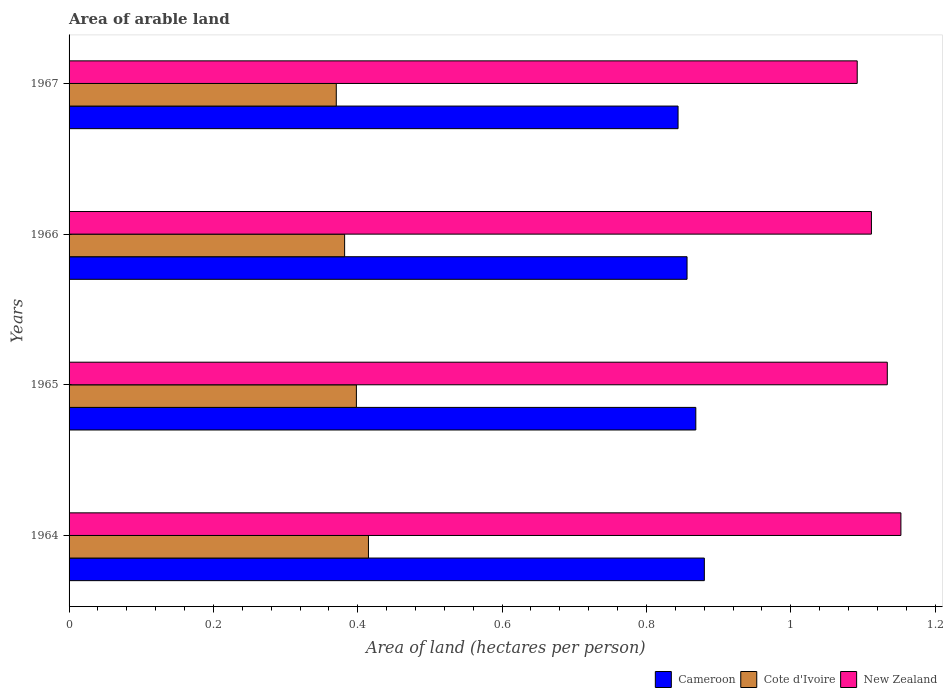How many different coloured bars are there?
Provide a short and direct response. 3. Are the number of bars per tick equal to the number of legend labels?
Offer a terse response. Yes. How many bars are there on the 4th tick from the top?
Make the answer very short. 3. How many bars are there on the 1st tick from the bottom?
Offer a terse response. 3. What is the label of the 4th group of bars from the top?
Make the answer very short. 1964. What is the total arable land in New Zealand in 1966?
Offer a very short reply. 1.11. Across all years, what is the maximum total arable land in Cote d'Ivoire?
Ensure brevity in your answer.  0.41. Across all years, what is the minimum total arable land in New Zealand?
Your answer should be compact. 1.09. In which year was the total arable land in Cameroon maximum?
Keep it short and to the point. 1964. In which year was the total arable land in Cameroon minimum?
Your response must be concise. 1967. What is the total total arable land in New Zealand in the graph?
Offer a terse response. 4.49. What is the difference between the total arable land in Cameroon in 1965 and that in 1967?
Provide a short and direct response. 0.02. What is the difference between the total arable land in Cote d'Ivoire in 1964 and the total arable land in Cameroon in 1967?
Keep it short and to the point. -0.43. What is the average total arable land in Cote d'Ivoire per year?
Keep it short and to the point. 0.39. In the year 1964, what is the difference between the total arable land in Cameroon and total arable land in Cote d'Ivoire?
Your answer should be very brief. 0.47. What is the ratio of the total arable land in Cameroon in 1965 to that in 1967?
Provide a short and direct response. 1.03. Is the difference between the total arable land in Cameroon in 1966 and 1967 greater than the difference between the total arable land in Cote d'Ivoire in 1966 and 1967?
Provide a short and direct response. Yes. What is the difference between the highest and the second highest total arable land in Cameroon?
Your answer should be very brief. 0.01. What is the difference between the highest and the lowest total arable land in Cote d'Ivoire?
Make the answer very short. 0.04. What does the 3rd bar from the top in 1966 represents?
Ensure brevity in your answer.  Cameroon. What does the 3rd bar from the bottom in 1966 represents?
Your answer should be compact. New Zealand. Is it the case that in every year, the sum of the total arable land in Cote d'Ivoire and total arable land in New Zealand is greater than the total arable land in Cameroon?
Make the answer very short. Yes. How many bars are there?
Provide a succinct answer. 12. How many years are there in the graph?
Your answer should be compact. 4. How are the legend labels stacked?
Offer a terse response. Horizontal. What is the title of the graph?
Offer a very short reply. Area of arable land. What is the label or title of the X-axis?
Provide a short and direct response. Area of land (hectares per person). What is the label or title of the Y-axis?
Make the answer very short. Years. What is the Area of land (hectares per person) of Cameroon in 1964?
Give a very brief answer. 0.88. What is the Area of land (hectares per person) in Cote d'Ivoire in 1964?
Your answer should be compact. 0.41. What is the Area of land (hectares per person) in New Zealand in 1964?
Your answer should be very brief. 1.15. What is the Area of land (hectares per person) of Cameroon in 1965?
Offer a very short reply. 0.87. What is the Area of land (hectares per person) of Cote d'Ivoire in 1965?
Your response must be concise. 0.4. What is the Area of land (hectares per person) in New Zealand in 1965?
Make the answer very short. 1.13. What is the Area of land (hectares per person) of Cameroon in 1966?
Provide a short and direct response. 0.86. What is the Area of land (hectares per person) in Cote d'Ivoire in 1966?
Offer a terse response. 0.38. What is the Area of land (hectares per person) of New Zealand in 1966?
Keep it short and to the point. 1.11. What is the Area of land (hectares per person) of Cameroon in 1967?
Your answer should be compact. 0.84. What is the Area of land (hectares per person) in Cote d'Ivoire in 1967?
Your response must be concise. 0.37. What is the Area of land (hectares per person) of New Zealand in 1967?
Make the answer very short. 1.09. Across all years, what is the maximum Area of land (hectares per person) of Cameroon?
Keep it short and to the point. 0.88. Across all years, what is the maximum Area of land (hectares per person) of Cote d'Ivoire?
Your response must be concise. 0.41. Across all years, what is the maximum Area of land (hectares per person) in New Zealand?
Offer a terse response. 1.15. Across all years, what is the minimum Area of land (hectares per person) in Cameroon?
Offer a very short reply. 0.84. Across all years, what is the minimum Area of land (hectares per person) in Cote d'Ivoire?
Your answer should be very brief. 0.37. Across all years, what is the minimum Area of land (hectares per person) of New Zealand?
Your answer should be compact. 1.09. What is the total Area of land (hectares per person) in Cameroon in the graph?
Provide a succinct answer. 3.45. What is the total Area of land (hectares per person) of Cote d'Ivoire in the graph?
Offer a very short reply. 1.57. What is the total Area of land (hectares per person) of New Zealand in the graph?
Your answer should be very brief. 4.49. What is the difference between the Area of land (hectares per person) of Cameroon in 1964 and that in 1965?
Your answer should be compact. 0.01. What is the difference between the Area of land (hectares per person) of Cote d'Ivoire in 1964 and that in 1965?
Offer a very short reply. 0.02. What is the difference between the Area of land (hectares per person) of New Zealand in 1964 and that in 1965?
Provide a succinct answer. 0.02. What is the difference between the Area of land (hectares per person) of Cameroon in 1964 and that in 1966?
Provide a short and direct response. 0.02. What is the difference between the Area of land (hectares per person) of Cote d'Ivoire in 1964 and that in 1966?
Your answer should be compact. 0.03. What is the difference between the Area of land (hectares per person) in New Zealand in 1964 and that in 1966?
Your response must be concise. 0.04. What is the difference between the Area of land (hectares per person) of Cameroon in 1964 and that in 1967?
Make the answer very short. 0.04. What is the difference between the Area of land (hectares per person) of Cote d'Ivoire in 1964 and that in 1967?
Your answer should be very brief. 0.04. What is the difference between the Area of land (hectares per person) of New Zealand in 1964 and that in 1967?
Offer a very short reply. 0.06. What is the difference between the Area of land (hectares per person) of Cameroon in 1965 and that in 1966?
Your answer should be very brief. 0.01. What is the difference between the Area of land (hectares per person) in Cote d'Ivoire in 1965 and that in 1966?
Your answer should be very brief. 0.02. What is the difference between the Area of land (hectares per person) of New Zealand in 1965 and that in 1966?
Your response must be concise. 0.02. What is the difference between the Area of land (hectares per person) in Cameroon in 1965 and that in 1967?
Keep it short and to the point. 0.02. What is the difference between the Area of land (hectares per person) in Cote d'Ivoire in 1965 and that in 1967?
Provide a succinct answer. 0.03. What is the difference between the Area of land (hectares per person) in New Zealand in 1965 and that in 1967?
Offer a terse response. 0.04. What is the difference between the Area of land (hectares per person) of Cameroon in 1966 and that in 1967?
Offer a terse response. 0.01. What is the difference between the Area of land (hectares per person) of Cote d'Ivoire in 1966 and that in 1967?
Offer a very short reply. 0.01. What is the difference between the Area of land (hectares per person) in New Zealand in 1966 and that in 1967?
Offer a very short reply. 0.02. What is the difference between the Area of land (hectares per person) in Cameroon in 1964 and the Area of land (hectares per person) in Cote d'Ivoire in 1965?
Your response must be concise. 0.48. What is the difference between the Area of land (hectares per person) of Cameroon in 1964 and the Area of land (hectares per person) of New Zealand in 1965?
Make the answer very short. -0.25. What is the difference between the Area of land (hectares per person) in Cote d'Ivoire in 1964 and the Area of land (hectares per person) in New Zealand in 1965?
Your answer should be very brief. -0.72. What is the difference between the Area of land (hectares per person) in Cameroon in 1964 and the Area of land (hectares per person) in Cote d'Ivoire in 1966?
Provide a succinct answer. 0.5. What is the difference between the Area of land (hectares per person) of Cameroon in 1964 and the Area of land (hectares per person) of New Zealand in 1966?
Your answer should be very brief. -0.23. What is the difference between the Area of land (hectares per person) in Cote d'Ivoire in 1964 and the Area of land (hectares per person) in New Zealand in 1966?
Your answer should be very brief. -0.7. What is the difference between the Area of land (hectares per person) of Cameroon in 1964 and the Area of land (hectares per person) of Cote d'Ivoire in 1967?
Provide a succinct answer. 0.51. What is the difference between the Area of land (hectares per person) of Cameroon in 1964 and the Area of land (hectares per person) of New Zealand in 1967?
Make the answer very short. -0.21. What is the difference between the Area of land (hectares per person) of Cote d'Ivoire in 1964 and the Area of land (hectares per person) of New Zealand in 1967?
Ensure brevity in your answer.  -0.68. What is the difference between the Area of land (hectares per person) in Cameroon in 1965 and the Area of land (hectares per person) in Cote d'Ivoire in 1966?
Provide a succinct answer. 0.49. What is the difference between the Area of land (hectares per person) of Cameroon in 1965 and the Area of land (hectares per person) of New Zealand in 1966?
Your answer should be very brief. -0.24. What is the difference between the Area of land (hectares per person) of Cote d'Ivoire in 1965 and the Area of land (hectares per person) of New Zealand in 1966?
Your answer should be compact. -0.71. What is the difference between the Area of land (hectares per person) in Cameroon in 1965 and the Area of land (hectares per person) in Cote d'Ivoire in 1967?
Your answer should be compact. 0.5. What is the difference between the Area of land (hectares per person) of Cameroon in 1965 and the Area of land (hectares per person) of New Zealand in 1967?
Keep it short and to the point. -0.22. What is the difference between the Area of land (hectares per person) in Cote d'Ivoire in 1965 and the Area of land (hectares per person) in New Zealand in 1967?
Offer a very short reply. -0.69. What is the difference between the Area of land (hectares per person) of Cameroon in 1966 and the Area of land (hectares per person) of Cote d'Ivoire in 1967?
Your answer should be very brief. 0.49. What is the difference between the Area of land (hectares per person) of Cameroon in 1966 and the Area of land (hectares per person) of New Zealand in 1967?
Your answer should be very brief. -0.24. What is the difference between the Area of land (hectares per person) of Cote d'Ivoire in 1966 and the Area of land (hectares per person) of New Zealand in 1967?
Keep it short and to the point. -0.71. What is the average Area of land (hectares per person) of Cameroon per year?
Provide a succinct answer. 0.86. What is the average Area of land (hectares per person) of Cote d'Ivoire per year?
Ensure brevity in your answer.  0.39. What is the average Area of land (hectares per person) of New Zealand per year?
Your answer should be compact. 1.12. In the year 1964, what is the difference between the Area of land (hectares per person) of Cameroon and Area of land (hectares per person) of Cote d'Ivoire?
Offer a very short reply. 0.47. In the year 1964, what is the difference between the Area of land (hectares per person) of Cameroon and Area of land (hectares per person) of New Zealand?
Your answer should be compact. -0.27. In the year 1964, what is the difference between the Area of land (hectares per person) in Cote d'Ivoire and Area of land (hectares per person) in New Zealand?
Provide a short and direct response. -0.74. In the year 1965, what is the difference between the Area of land (hectares per person) in Cameroon and Area of land (hectares per person) in Cote d'Ivoire?
Your answer should be very brief. 0.47. In the year 1965, what is the difference between the Area of land (hectares per person) of Cameroon and Area of land (hectares per person) of New Zealand?
Make the answer very short. -0.27. In the year 1965, what is the difference between the Area of land (hectares per person) of Cote d'Ivoire and Area of land (hectares per person) of New Zealand?
Keep it short and to the point. -0.74. In the year 1966, what is the difference between the Area of land (hectares per person) in Cameroon and Area of land (hectares per person) in Cote d'Ivoire?
Your response must be concise. 0.47. In the year 1966, what is the difference between the Area of land (hectares per person) in Cameroon and Area of land (hectares per person) in New Zealand?
Make the answer very short. -0.26. In the year 1966, what is the difference between the Area of land (hectares per person) of Cote d'Ivoire and Area of land (hectares per person) of New Zealand?
Your answer should be compact. -0.73. In the year 1967, what is the difference between the Area of land (hectares per person) of Cameroon and Area of land (hectares per person) of Cote d'Ivoire?
Provide a succinct answer. 0.47. In the year 1967, what is the difference between the Area of land (hectares per person) of Cameroon and Area of land (hectares per person) of New Zealand?
Provide a short and direct response. -0.25. In the year 1967, what is the difference between the Area of land (hectares per person) in Cote d'Ivoire and Area of land (hectares per person) in New Zealand?
Your response must be concise. -0.72. What is the ratio of the Area of land (hectares per person) in Cameroon in 1964 to that in 1965?
Your answer should be very brief. 1.01. What is the ratio of the Area of land (hectares per person) of Cote d'Ivoire in 1964 to that in 1965?
Provide a succinct answer. 1.04. What is the ratio of the Area of land (hectares per person) in New Zealand in 1964 to that in 1965?
Offer a very short reply. 1.02. What is the ratio of the Area of land (hectares per person) in Cameroon in 1964 to that in 1966?
Give a very brief answer. 1.03. What is the ratio of the Area of land (hectares per person) in Cote d'Ivoire in 1964 to that in 1966?
Provide a short and direct response. 1.09. What is the ratio of the Area of land (hectares per person) of New Zealand in 1964 to that in 1966?
Keep it short and to the point. 1.04. What is the ratio of the Area of land (hectares per person) in Cameroon in 1964 to that in 1967?
Ensure brevity in your answer.  1.04. What is the ratio of the Area of land (hectares per person) in Cote d'Ivoire in 1964 to that in 1967?
Offer a terse response. 1.12. What is the ratio of the Area of land (hectares per person) in New Zealand in 1964 to that in 1967?
Your response must be concise. 1.06. What is the ratio of the Area of land (hectares per person) in Cameroon in 1965 to that in 1966?
Your response must be concise. 1.01. What is the ratio of the Area of land (hectares per person) of Cote d'Ivoire in 1965 to that in 1966?
Your answer should be very brief. 1.04. What is the ratio of the Area of land (hectares per person) in New Zealand in 1965 to that in 1966?
Make the answer very short. 1.02. What is the ratio of the Area of land (hectares per person) in Cameroon in 1965 to that in 1967?
Provide a short and direct response. 1.03. What is the ratio of the Area of land (hectares per person) in Cote d'Ivoire in 1965 to that in 1967?
Give a very brief answer. 1.08. What is the ratio of the Area of land (hectares per person) of New Zealand in 1965 to that in 1967?
Make the answer very short. 1.04. What is the ratio of the Area of land (hectares per person) of Cameroon in 1966 to that in 1967?
Provide a succinct answer. 1.01. What is the ratio of the Area of land (hectares per person) of Cote d'Ivoire in 1966 to that in 1967?
Your response must be concise. 1.03. What is the ratio of the Area of land (hectares per person) in New Zealand in 1966 to that in 1967?
Give a very brief answer. 1.02. What is the difference between the highest and the second highest Area of land (hectares per person) in Cameroon?
Ensure brevity in your answer.  0.01. What is the difference between the highest and the second highest Area of land (hectares per person) in Cote d'Ivoire?
Provide a succinct answer. 0.02. What is the difference between the highest and the second highest Area of land (hectares per person) in New Zealand?
Give a very brief answer. 0.02. What is the difference between the highest and the lowest Area of land (hectares per person) of Cameroon?
Ensure brevity in your answer.  0.04. What is the difference between the highest and the lowest Area of land (hectares per person) of Cote d'Ivoire?
Offer a very short reply. 0.04. What is the difference between the highest and the lowest Area of land (hectares per person) in New Zealand?
Make the answer very short. 0.06. 